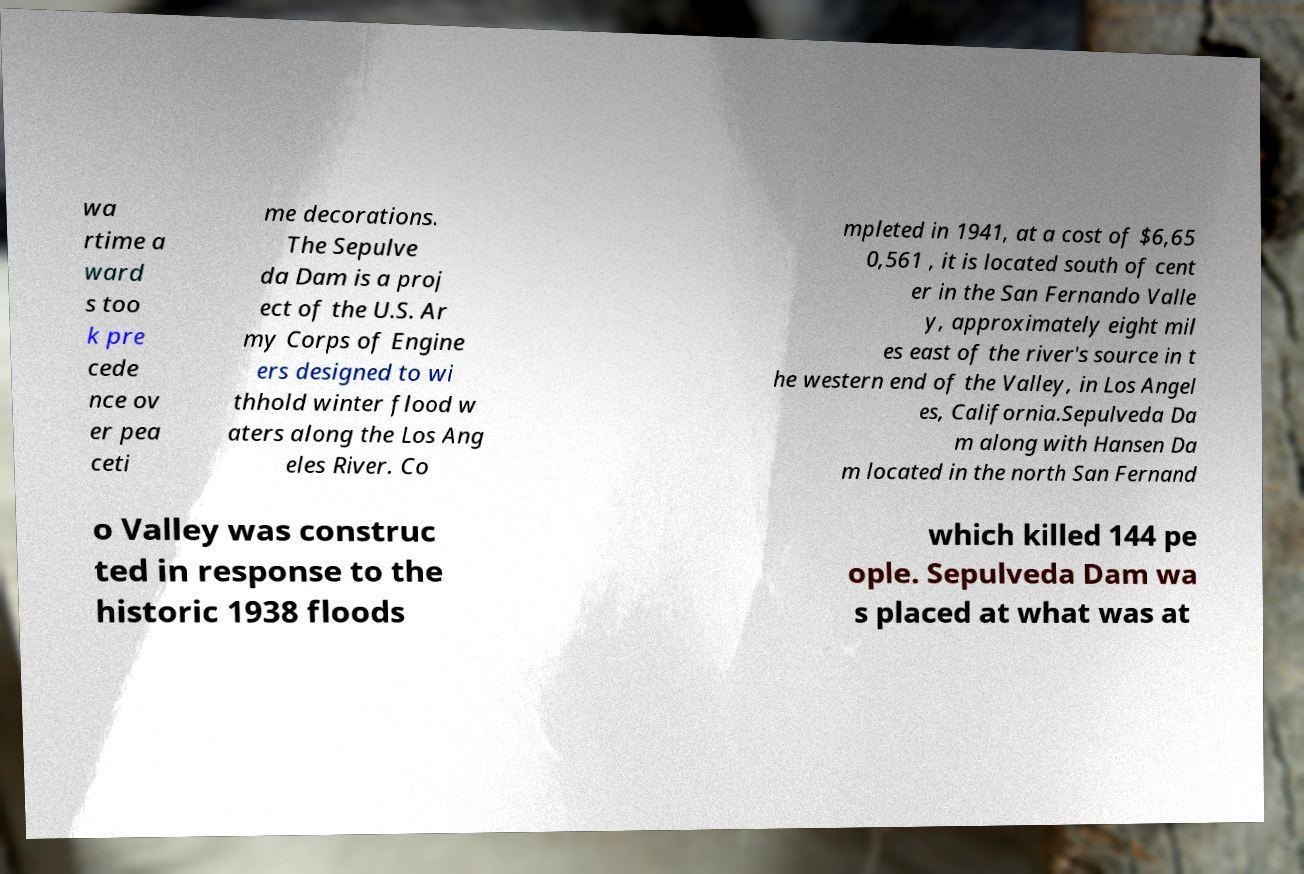There's text embedded in this image that I need extracted. Can you transcribe it verbatim? wa rtime a ward s too k pre cede nce ov er pea ceti me decorations. The Sepulve da Dam is a proj ect of the U.S. Ar my Corps of Engine ers designed to wi thhold winter flood w aters along the Los Ang eles River. Co mpleted in 1941, at a cost of $6,65 0,561 , it is located south of cent er in the San Fernando Valle y, approximately eight mil es east of the river's source in t he western end of the Valley, in Los Angel es, California.Sepulveda Da m along with Hansen Da m located in the north San Fernand o Valley was construc ted in response to the historic 1938 floods which killed 144 pe ople. Sepulveda Dam wa s placed at what was at 